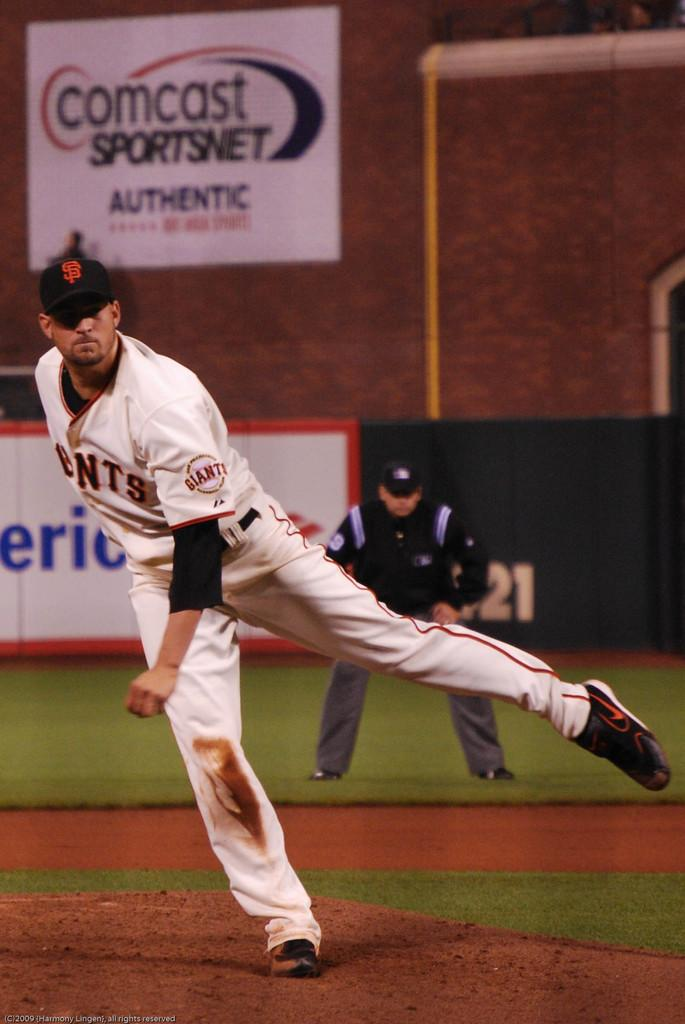<image>
Describe the image concisely. Baseball pitcher wearing a uniform with Giants on the left arm of his jersey. 